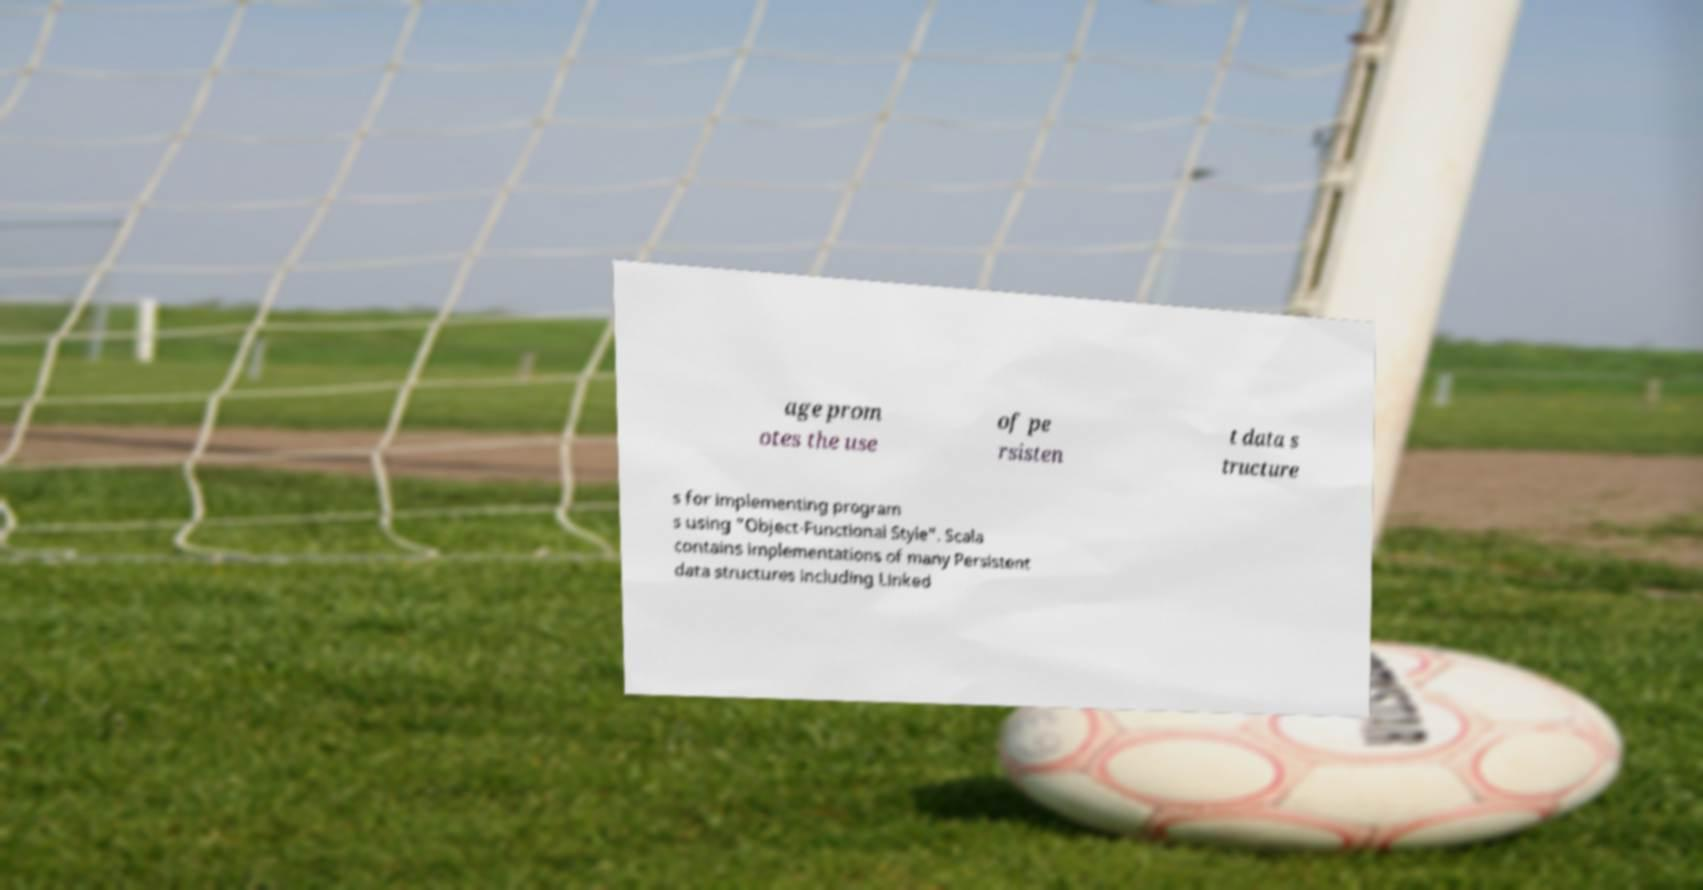Could you assist in decoding the text presented in this image and type it out clearly? age prom otes the use of pe rsisten t data s tructure s for implementing program s using "Object-Functional Style". Scala contains implementations of many Persistent data structures including Linked 